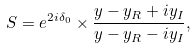Convert formula to latex. <formula><loc_0><loc_0><loc_500><loc_500>S = e ^ { 2 i \delta _ { 0 } } \times \frac { y - y _ { R } + i y _ { I } } { y - y _ { R } - i y _ { I } } ,</formula> 